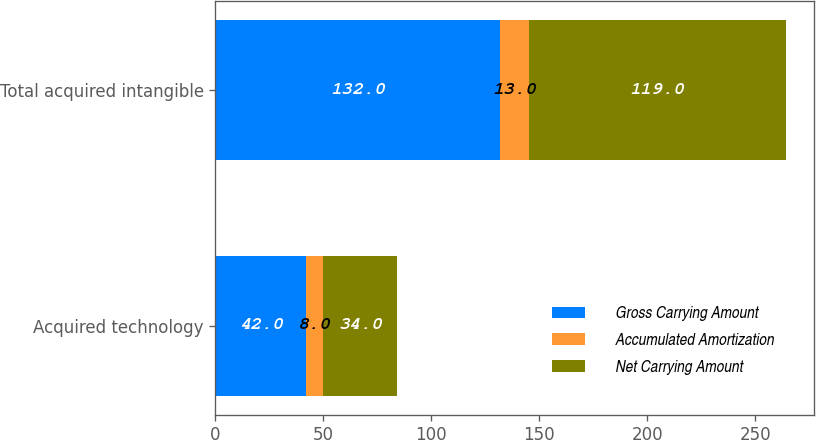Convert chart to OTSL. <chart><loc_0><loc_0><loc_500><loc_500><stacked_bar_chart><ecel><fcel>Acquired technology<fcel>Total acquired intangible<nl><fcel>Gross Carrying Amount<fcel>42<fcel>132<nl><fcel>Accumulated Amortization<fcel>8<fcel>13<nl><fcel>Net Carrying Amount<fcel>34<fcel>119<nl></chart> 